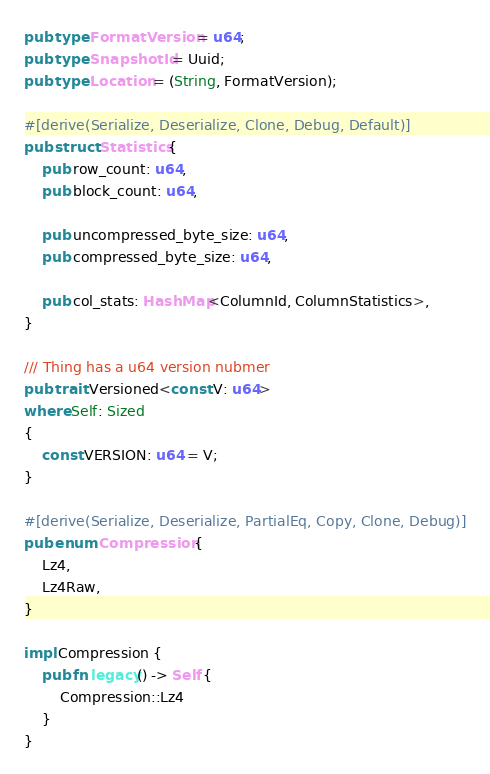<code> <loc_0><loc_0><loc_500><loc_500><_Rust_>pub type FormatVersion = u64;
pub type SnapshotId = Uuid;
pub type Location = (String, FormatVersion);

#[derive(Serialize, Deserialize, Clone, Debug, Default)]
pub struct Statistics {
    pub row_count: u64,
    pub block_count: u64,

    pub uncompressed_byte_size: u64,
    pub compressed_byte_size: u64,

    pub col_stats: HashMap<ColumnId, ColumnStatistics>,
}

/// Thing has a u64 version nubmer
pub trait Versioned<const V: u64>
where Self: Sized
{
    const VERSION: u64 = V;
}

#[derive(Serialize, Deserialize, PartialEq, Copy, Clone, Debug)]
pub enum Compression {
    Lz4,
    Lz4Raw,
}

impl Compression {
    pub fn legacy() -> Self {
        Compression::Lz4
    }
}
</code> 